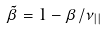<formula> <loc_0><loc_0><loc_500><loc_500>\tilde { \beta } = 1 - \beta / \nu _ { | | }</formula> 